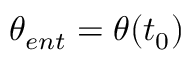Convert formula to latex. <formula><loc_0><loc_0><loc_500><loc_500>\theta _ { e n t } = \theta ( t _ { 0 } )</formula> 